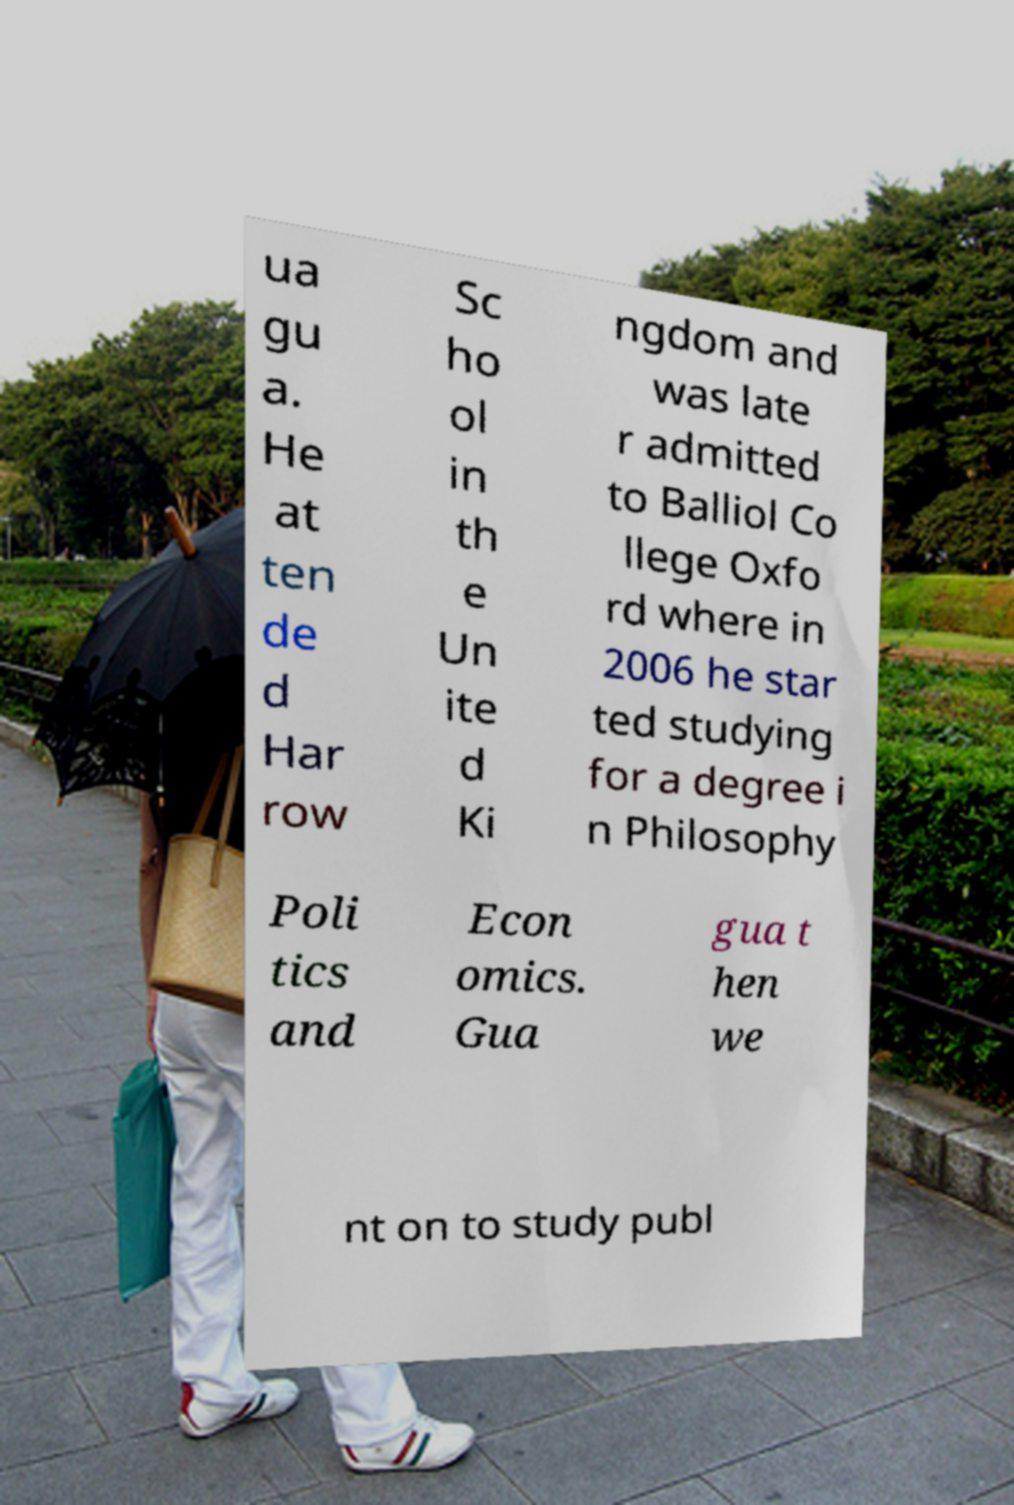Please read and relay the text visible in this image. What does it say? ua gu a. He at ten de d Har row Sc ho ol in th e Un ite d Ki ngdom and was late r admitted to Balliol Co llege Oxfo rd where in 2006 he star ted studying for a degree i n Philosophy Poli tics and Econ omics. Gua gua t hen we nt on to study publ 